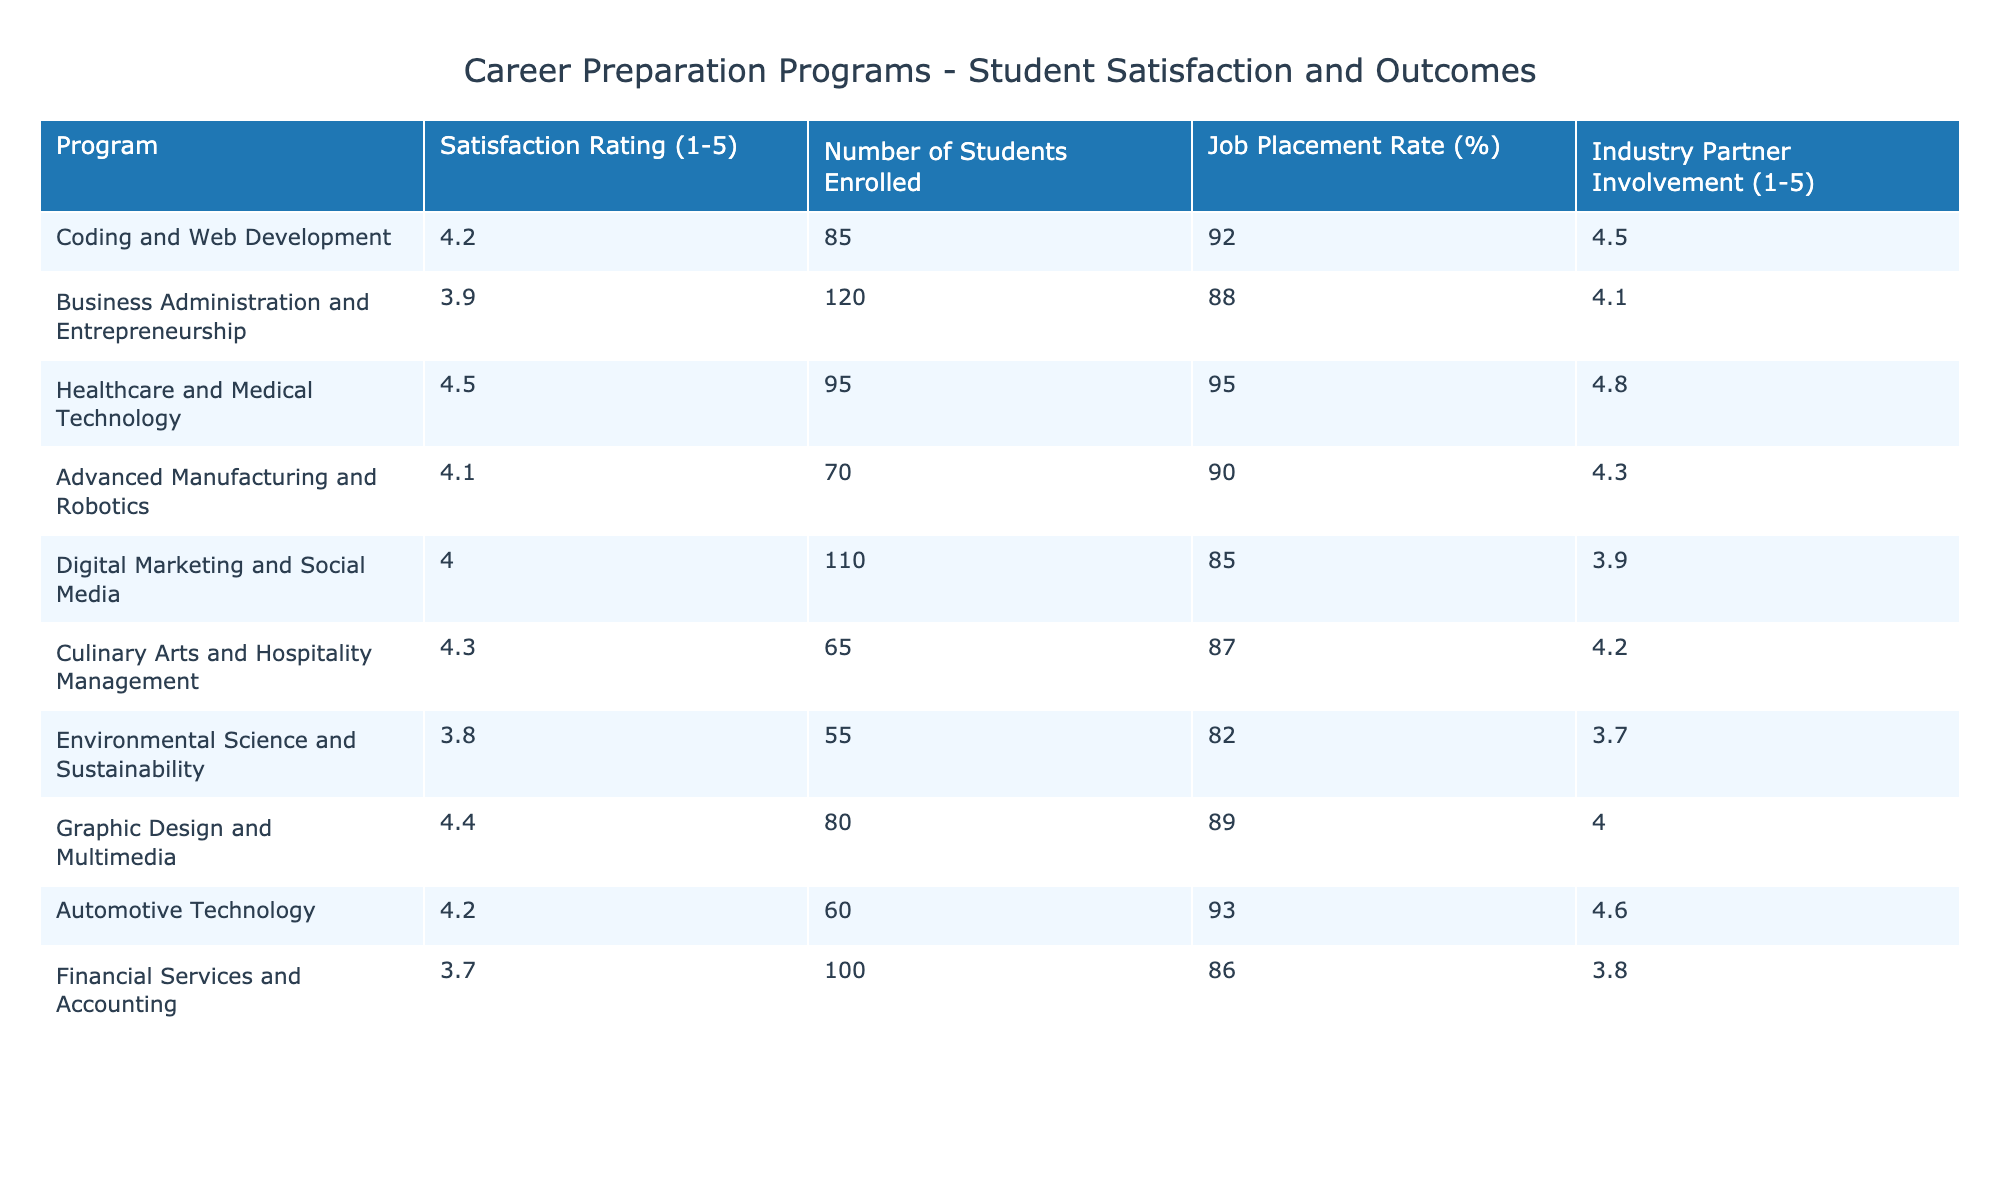What is the satisfaction rating for the Healthcare and Medical Technology program? The satisfaction rating for the Healthcare and Medical Technology program is directly listed in the table. It shows a rating of 4.5.
Answer: 4.5 Which program has the highest job placement rate? By examining the job placement rates in the table, the Healthcare and Medical Technology program has the highest rate of 95%.
Answer: Healthcare and Medical Technology What is the average satisfaction rating of all programs? To find the average satisfaction rating, we add all the ratings (4.2 + 3.9 + 4.5 + 4.1 + 4.0 + 4.3 + 3.8 + 4.4 + 4.2 + 3.7 = 43.2) and then divide by the number of programs (10). So, 43.2 / 10 = 4.32.
Answer: 4.32 Is the satisfaction rating for Financial Services and Accounting higher than 4.0? The satisfaction rating for Financial Services and Accounting is 3.7, which is below 4.0.
Answer: No What is the difference in satisfaction ratings between the highest-rated program and the lowest-rated program? The highest satisfaction rating is for Healthcare and Medical Technology (4.5) and the lowest is for Environmental Science and Sustainability (3.8). The difference is 4.5 - 3.8 = 0.7.
Answer: 0.7 Which program has both a satisfaction rating and job placement rate above 90%? Looking at the table, the programs that meet both criteria are Healthcare and Medical Technology (satisfaction 4.5, job placement 95%) and Automotive Technology (satisfaction 4.2, job placement 93%).
Answer: Healthcare and Medical Technology, Automotive Technology What is the total number of students enrolled in all programs? To find the total number of students enrolled, add the enrollment numbers from the table: 85 + 120 + 95 + 70 + 110 + 65 + 55 + 80 + 60 + 100 =  1000.
Answer: 1000 Is the Industry Partner Involvement for Digital Marketing and Social Media higher than the average involvement across all programs? The average involvement rating is calculated as (4.5 + 4.1 + 4.8 + 4.3 + 3.9 + 4.2 + 3.7 + 4.0 + 4.6 + 3.8) / 10 = 4.2. The rating for Digital Marketing and Social Media is 3.9, which is lower than 4.2.
Answer: No What are the two programs with the highest Industry Partner Involvement ratings? The programs with the highest ratings are Healthcare and Medical Technology (4.8) and Automotive Technology (4.6).
Answer: Healthcare and Medical Technology, Automotive Technology 